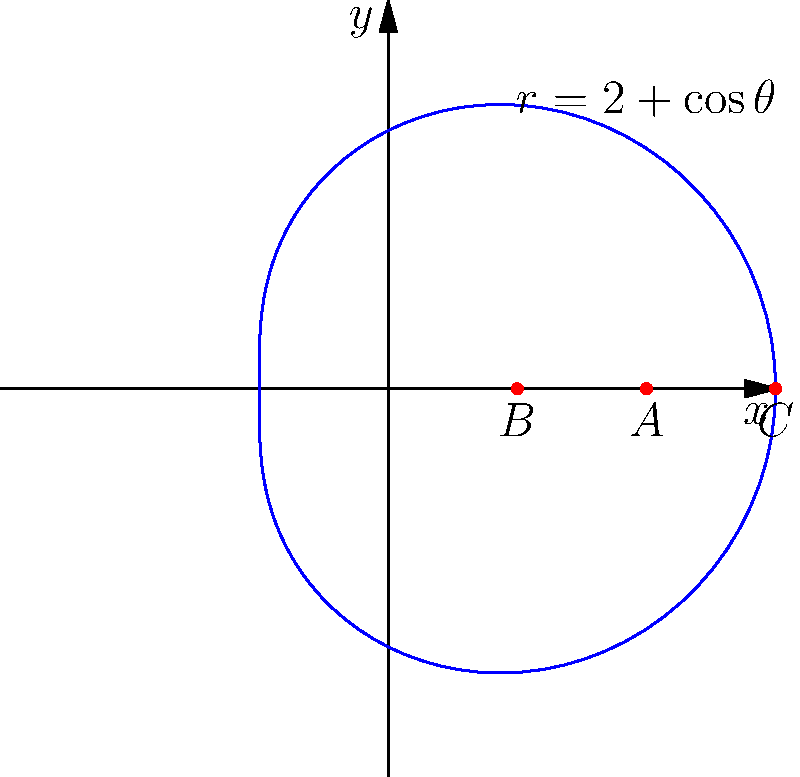In your custom Minecraft plugin for projectile trajectories, you're using a polar coordinate system to represent the path of an arrow. The trajectory is described by the equation $r = 2 + \cos\theta$. If an arrow is fired from point A (2,0), what is the total distance traveled by the arrow as it moves from point A to point B (1,0), then from B to C (3,0) along the curve? To solve this problem, we need to calculate the arc length of the curve between the given points. Let's break it down step-by-step:

1) The formula for arc length in polar coordinates is:
   $$s = \int_{\theta_1}^{\theta_2} \sqrt{r^2 + \left(\frac{dr}{d\theta}\right)^2} d\theta$$

2) For our curve, $r = 2 + \cos\theta$. We need to find $\frac{dr}{d\theta}$:
   $$\frac{dr}{d\theta} = -\sin\theta$$

3) Substituting into the arc length formula:
   $$s = \int_{\theta_1}^{\theta_2} \sqrt{(2+\cos\theta)^2 + (-\sin\theta)^2} d\theta$$

4) Simplify under the square root:
   $$s = \int_{\theta_1}^{\theta_2} \sqrt{4+4\cos\theta+\cos^2\theta + \sin^2\theta} d\theta$$
   $$s = \int_{\theta_1}^{\theta_2} \sqrt{5+4\cos\theta} d\theta$$

5) To find $\theta$ values for points A, B, and C:
   A (2,0): $\theta_A = 0$
   B (1,0): $\theta_B = \arccos(-1) = \pi$
   C (3,0): $\theta_C = \arccos(1) = 0$ or $2\pi$

6) The total distance is the sum of AB and BC:
   $$s_{total} = \int_0^{\pi} \sqrt{5+4\cos\theta} d\theta + \int_{\pi}^{2\pi} \sqrt{5+4\cos\theta} d\theta$$

7) This integral doesn't have an elementary antiderivative, so we need to use numerical methods or special functions to evaluate it. Using a numerical integration tool, we get:

   $$s_{total} \approx 7.64$$

Therefore, the total distance traveled by the arrow is approximately 7.64 units.
Answer: 7.64 units 